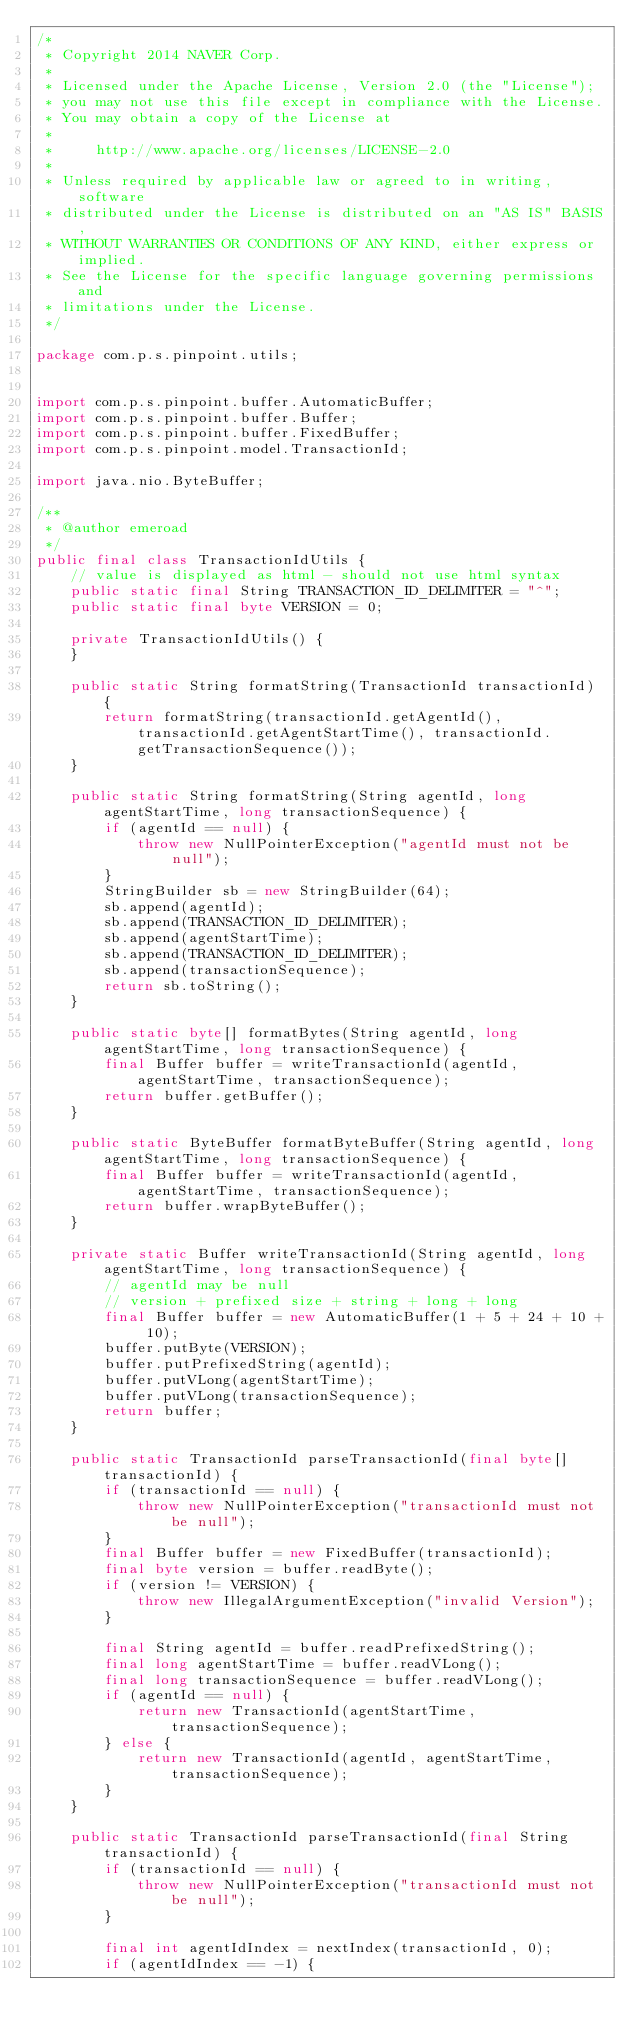<code> <loc_0><loc_0><loc_500><loc_500><_Java_>/*
 * Copyright 2014 NAVER Corp.
 *
 * Licensed under the Apache License, Version 2.0 (the "License");
 * you may not use this file except in compliance with the License.
 * You may obtain a copy of the License at
 *
 *     http://www.apache.org/licenses/LICENSE-2.0
 *
 * Unless required by applicable law or agreed to in writing, software
 * distributed under the License is distributed on an "AS IS" BASIS,
 * WITHOUT WARRANTIES OR CONDITIONS OF ANY KIND, either express or implied.
 * See the License for the specific language governing permissions and
 * limitations under the License.
 */

package com.p.s.pinpoint.utils;


import com.p.s.pinpoint.buffer.AutomaticBuffer;
import com.p.s.pinpoint.buffer.Buffer;
import com.p.s.pinpoint.buffer.FixedBuffer;
import com.p.s.pinpoint.model.TransactionId;

import java.nio.ByteBuffer;

/**
 * @author emeroad
 */
public final class TransactionIdUtils {
    // value is displayed as html - should not use html syntax
    public static final String TRANSACTION_ID_DELIMITER = "^";
    public static final byte VERSION = 0;

    private TransactionIdUtils() {
    }

    public static String formatString(TransactionId transactionId) {
        return formatString(transactionId.getAgentId(), transactionId.getAgentStartTime(), transactionId.getTransactionSequence());
    }

    public static String formatString(String agentId, long agentStartTime, long transactionSequence) {
        if (agentId == null) {
            throw new NullPointerException("agentId must not be null");
        }
        StringBuilder sb = new StringBuilder(64);
        sb.append(agentId);
        sb.append(TRANSACTION_ID_DELIMITER);
        sb.append(agentStartTime);
        sb.append(TRANSACTION_ID_DELIMITER);
        sb.append(transactionSequence);
        return sb.toString();
    }

    public static byte[] formatBytes(String agentId, long agentStartTime, long transactionSequence) {
        final Buffer buffer = writeTransactionId(agentId, agentStartTime, transactionSequence);
        return buffer.getBuffer();
    }

    public static ByteBuffer formatByteBuffer(String agentId, long agentStartTime, long transactionSequence) {
        final Buffer buffer = writeTransactionId(agentId, agentStartTime, transactionSequence);
        return buffer.wrapByteBuffer();
    }

    private static Buffer writeTransactionId(String agentId, long agentStartTime, long transactionSequence) {
        // agentId may be null
        // version + prefixed size + string + long + long
        final Buffer buffer = new AutomaticBuffer(1 + 5 + 24 + 10 + 10);
        buffer.putByte(VERSION);
        buffer.putPrefixedString(agentId);
        buffer.putVLong(agentStartTime);
        buffer.putVLong(transactionSequence);
        return buffer;
    }

    public static TransactionId parseTransactionId(final byte[] transactionId) {
        if (transactionId == null) {
            throw new NullPointerException("transactionId must not be null");
        }
        final Buffer buffer = new FixedBuffer(transactionId);
        final byte version = buffer.readByte();
        if (version != VERSION) {
            throw new IllegalArgumentException("invalid Version");
        }

        final String agentId = buffer.readPrefixedString();
        final long agentStartTime = buffer.readVLong();
        final long transactionSequence = buffer.readVLong();
        if (agentId == null) {
            return new TransactionId(agentStartTime, transactionSequence);
        } else {
            return new TransactionId(agentId, agentStartTime,transactionSequence);
        }
    }

    public static TransactionId parseTransactionId(final String transactionId) {
        if (transactionId == null) {
            throw new NullPointerException("transactionId must not be null");
        }

        final int agentIdIndex = nextIndex(transactionId, 0);
        if (agentIdIndex == -1) {</code> 